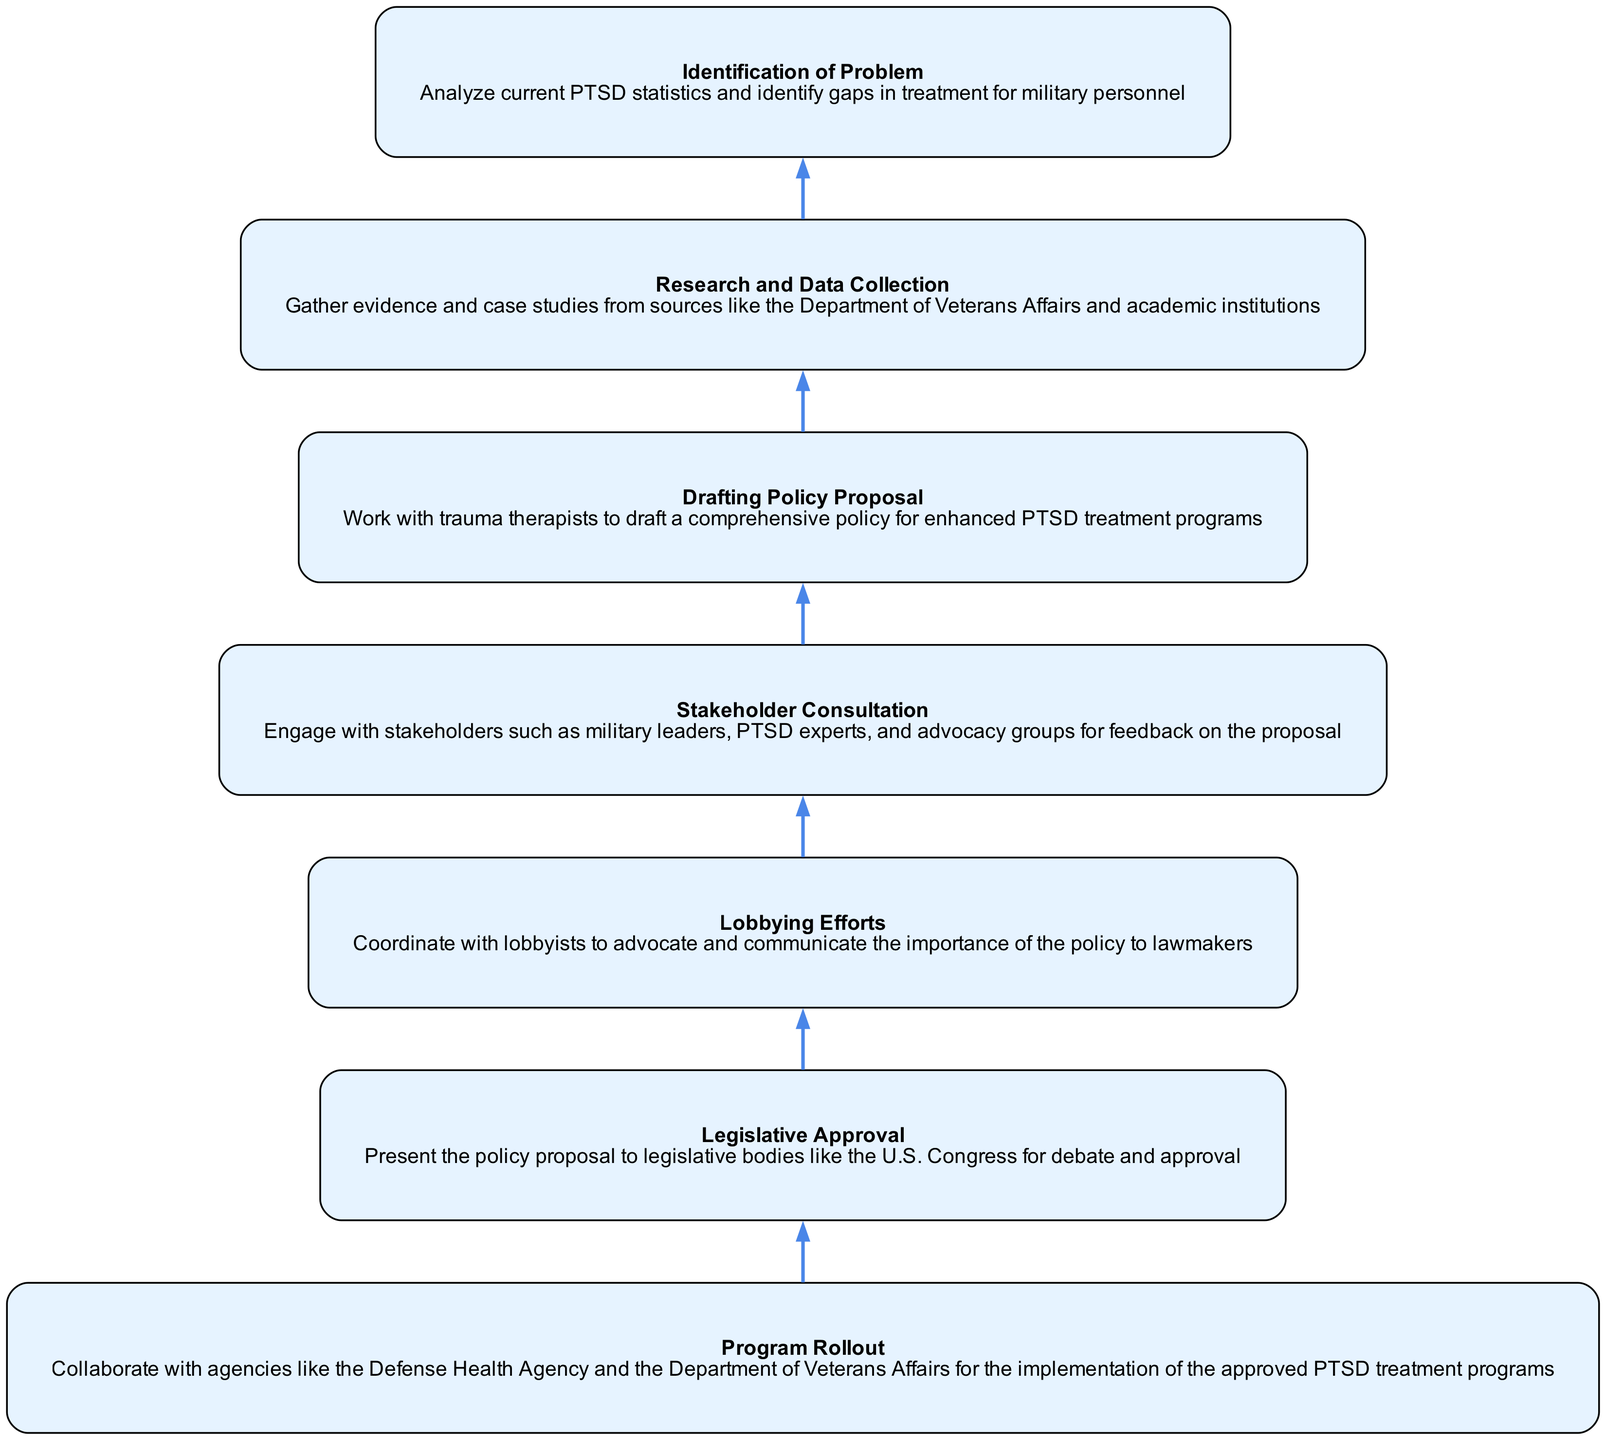What is the first step in the advocacy campaign? The first step in the advocacy campaign is to analyze current PTSD statistics and identify gaps in treatment for military personnel. This is visually represented as "Identification of Problem" in the diagram.
Answer: Identification of Problem How many total steps are in the advocacy campaign? To find the total steps, we count each individual node in the diagram. There are seven distinct steps represented.
Answer: 7 What follows after the "Drafting Policy Proposal"? After "Drafting Policy Proposal," the next step is "Stakeholder Consultation" as depicted by the directed edge in the flow chart that connects these two nodes.
Answer: Stakeholder Consultation Which step involves engaging with military leaders and advocacy groups? The step that involves engaging with military leaders and advocacy groups for feedback on the proposal is "Stakeholder Consultation," indicated in the diagram.
Answer: Stakeholder Consultation What is the final step in the advocacy campaign? The final step of the advocacy campaign as per the diagram is the "Program Rollout," which indicates the implementation phase of the approved PTSD treatment programs.
Answer: Program Rollout How many distinct stakeholders are mentioned in the consultation step? The consultation step mentions several categories of stakeholders, including military leaders, PTSD experts, and advocacy groups, which gives us three distinct types of stakeholders referenced.
Answer: 3 What is the relationship between "Lobbying Efforts" and "Legislative Approval"? The relationship is sequential; "Lobbying Efforts" must be completed before the "Legislative Approval" step can take place. In the flow chart, there is a direct edge leading from "Lobbying Efforts" to "Legislative Approval," indicating this order.
Answer: Sequential Which policy drafting involves trauma therapists? The "Drafting Policy Proposal" explicitly mentions working with trauma therapists to create the comprehensive policy for enhanced PTSD treatment programs. This is directly stated in the step's description.
Answer: Drafting Policy Proposal What is the primary action in the "Research and Data Collection" step? The primary action in this step is to gather evidence and case studies from relevant sources to support the advocacy campaign. This is described in the step itself, highlighting the data collection aspect.
Answer: Gather evidence and case studies 